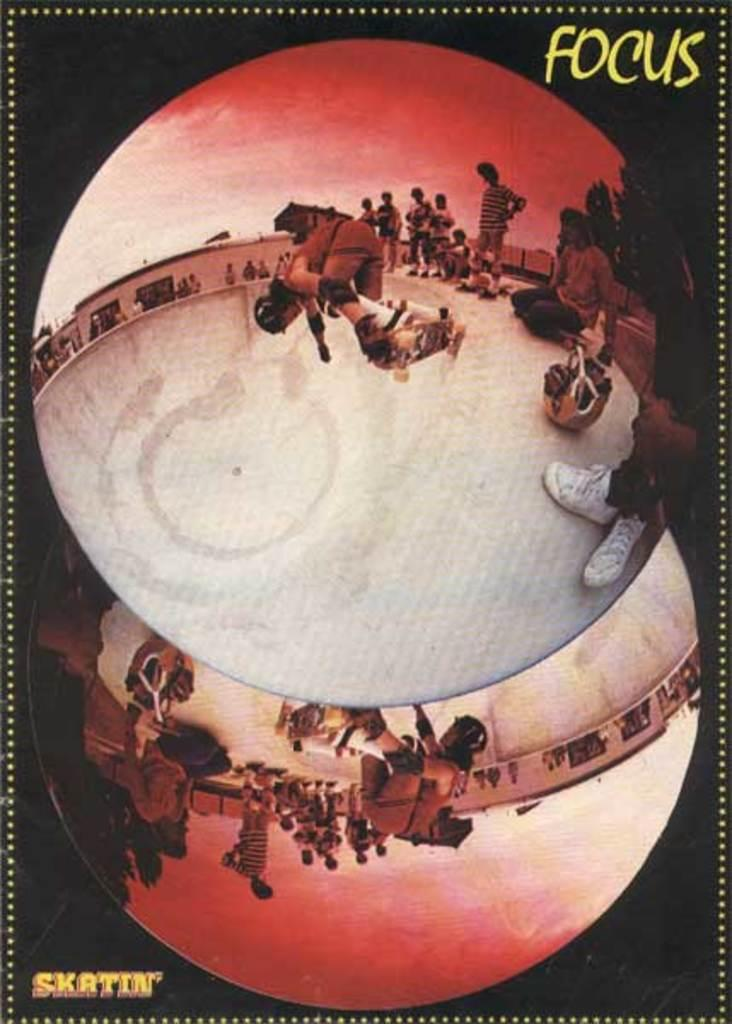<image>
Present a compact description of the photo's key features. A poster features pictures of skateboarders and says "focus" at the top. 